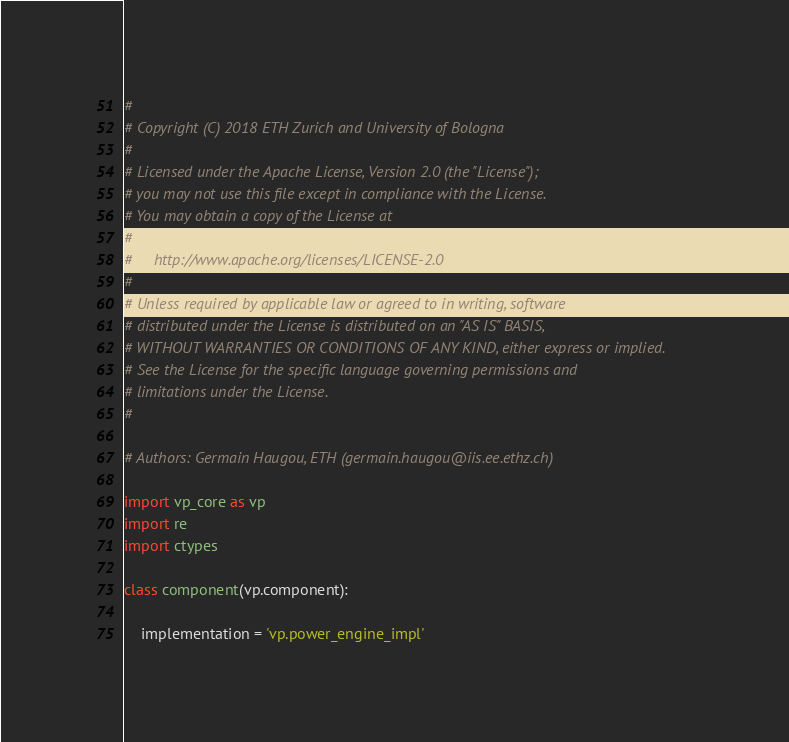<code> <loc_0><loc_0><loc_500><loc_500><_Python_>#
# Copyright (C) 2018 ETH Zurich and University of Bologna
#
# Licensed under the Apache License, Version 2.0 (the "License");
# you may not use this file except in compliance with the License.
# You may obtain a copy of the License at
#
#     http://www.apache.org/licenses/LICENSE-2.0
#
# Unless required by applicable law or agreed to in writing, software
# distributed under the License is distributed on an "AS IS" BASIS,
# WITHOUT WARRANTIES OR CONDITIONS OF ANY KIND, either express or implied.
# See the License for the specific language governing permissions and
# limitations under the License.
#

# Authors: Germain Haugou, ETH (germain.haugou@iis.ee.ethz.ch)
 
import vp_core as vp
import re
import ctypes

class component(vp.component):

    implementation = 'vp.power_engine_impl'
</code> 